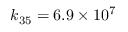Convert formula to latex. <formula><loc_0><loc_0><loc_500><loc_500>k _ { 3 5 } = 6 . 9 \times 1 0 ^ { 7 }</formula> 